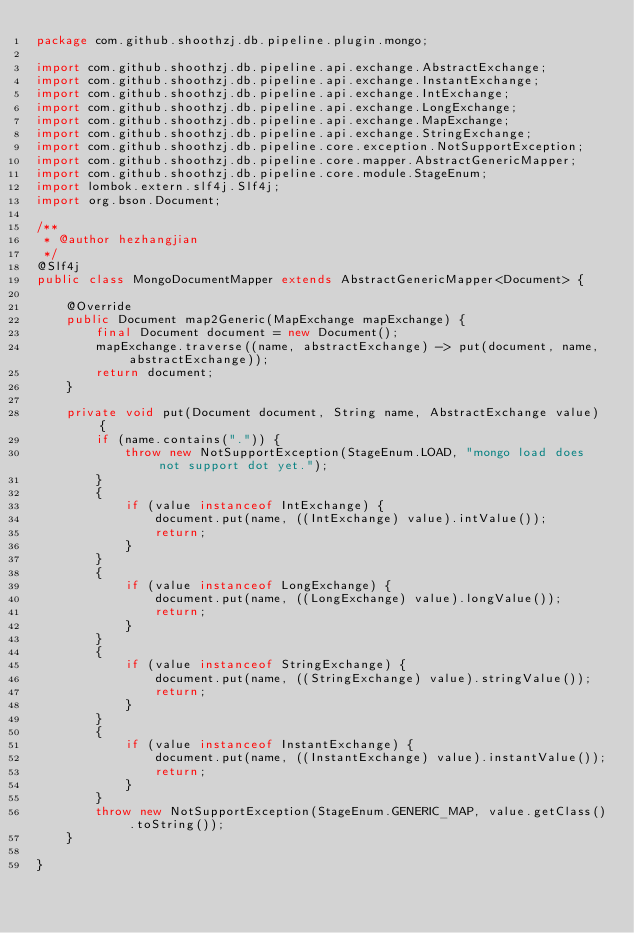Convert code to text. <code><loc_0><loc_0><loc_500><loc_500><_Java_>package com.github.shoothzj.db.pipeline.plugin.mongo;

import com.github.shoothzj.db.pipeline.api.exchange.AbstractExchange;
import com.github.shoothzj.db.pipeline.api.exchange.InstantExchange;
import com.github.shoothzj.db.pipeline.api.exchange.IntExchange;
import com.github.shoothzj.db.pipeline.api.exchange.LongExchange;
import com.github.shoothzj.db.pipeline.api.exchange.MapExchange;
import com.github.shoothzj.db.pipeline.api.exchange.StringExchange;
import com.github.shoothzj.db.pipeline.core.exception.NotSupportException;
import com.github.shoothzj.db.pipeline.core.mapper.AbstractGenericMapper;
import com.github.shoothzj.db.pipeline.core.module.StageEnum;
import lombok.extern.slf4j.Slf4j;
import org.bson.Document;

/**
 * @author hezhangjian
 */
@Slf4j
public class MongoDocumentMapper extends AbstractGenericMapper<Document> {

    @Override
    public Document map2Generic(MapExchange mapExchange) {
        final Document document = new Document();
        mapExchange.traverse((name, abstractExchange) -> put(document, name, abstractExchange));
        return document;
    }

    private void put(Document document, String name, AbstractExchange value) {
        if (name.contains(".")) {
            throw new NotSupportException(StageEnum.LOAD, "mongo load does not support dot yet.");
        }
        {
            if (value instanceof IntExchange) {
                document.put(name, ((IntExchange) value).intValue());
                return;
            }
        }
        {
            if (value instanceof LongExchange) {
                document.put(name, ((LongExchange) value).longValue());
                return;
            }
        }
        {
            if (value instanceof StringExchange) {
                document.put(name, ((StringExchange) value).stringValue());
                return;
            }
        }
        {
            if (value instanceof InstantExchange) {
                document.put(name, ((InstantExchange) value).instantValue());
                return;
            }
        }
        throw new NotSupportException(StageEnum.GENERIC_MAP, value.getClass().toString());
    }

}
</code> 